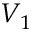Convert formula to latex. <formula><loc_0><loc_0><loc_500><loc_500>V _ { 1 }</formula> 